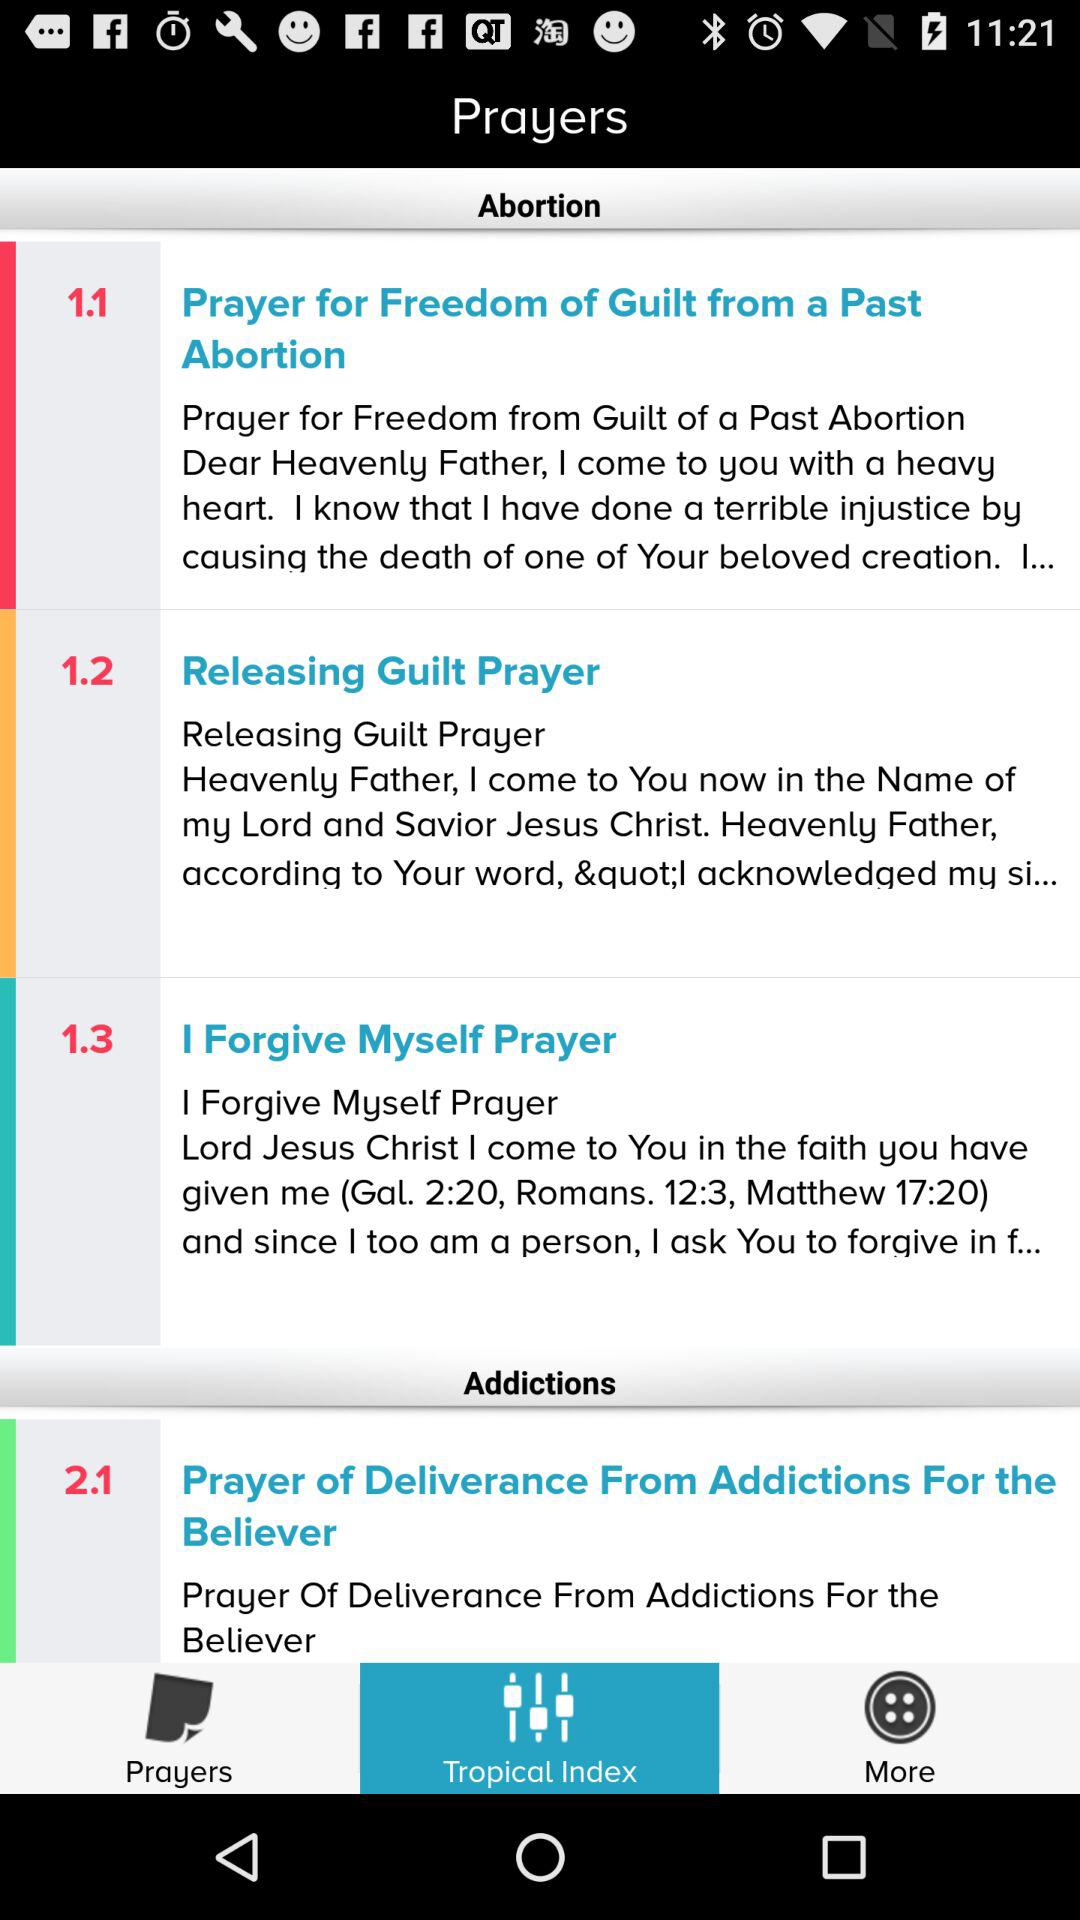How many prayer categories are there?
Answer the question using a single word or phrase. 2 